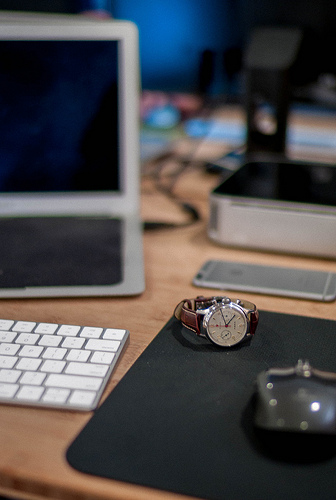<image>
Is there a watch on the mousepad? Yes. Looking at the image, I can see the watch is positioned on top of the mousepad, with the mousepad providing support. 